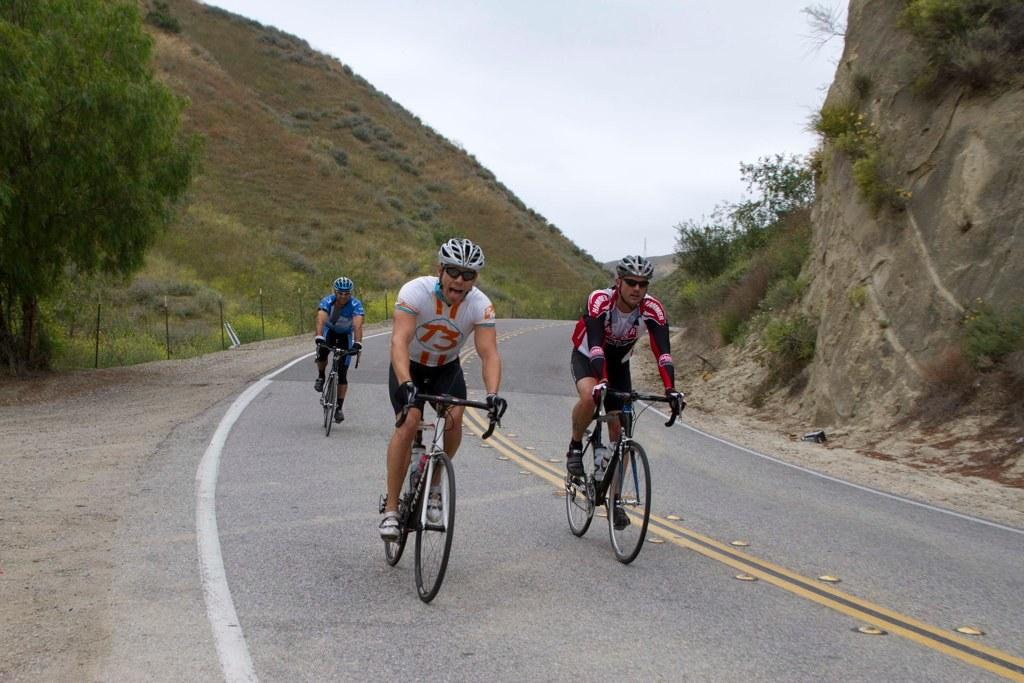How many people are in the image? There are three people in the image. What are the people doing in the image? The people are riding bicycles. What safety equipment are the people wearing? The people are wearing helmets. What type of eyewear are the people wearing? The people are wearing glasses. What can be seen on either side of the road in the image? There are hills, plants, and trees on either side of the road. What is present on the left side of the road? There are fences on the left side of the road. What is the condition of the sky in the image? The sky is clear in the image. What type of cub is visible in the image? There is no cub present in the image. What type of lamp can be seen illuminating the road in the image? There are no lamps present in the image; it is a clear day with natural light. 